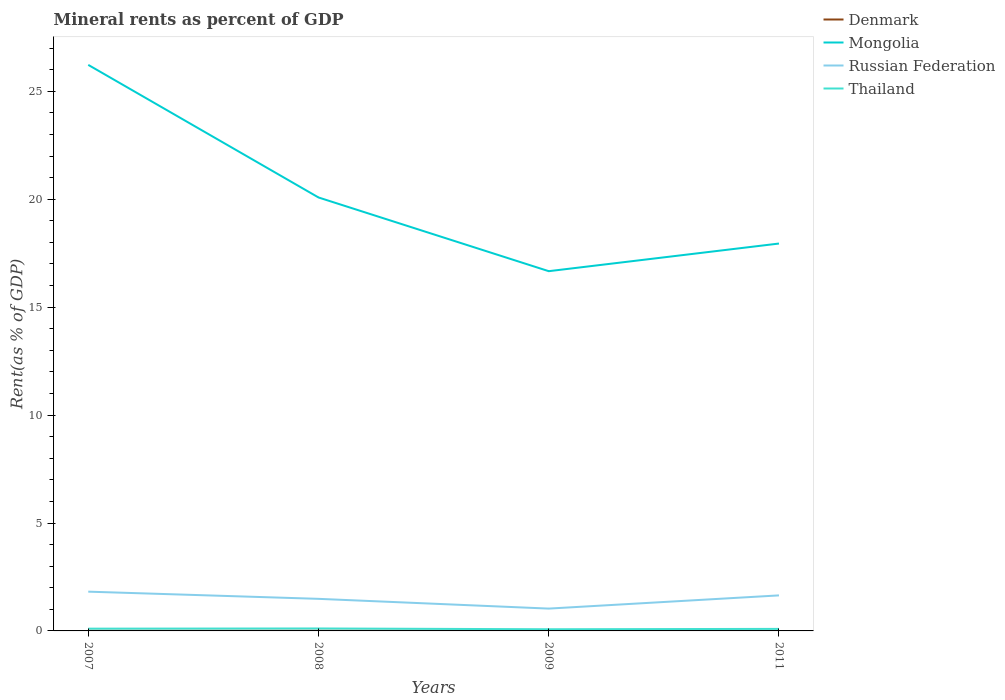Across all years, what is the maximum mineral rent in Thailand?
Your answer should be compact. 0.08. What is the total mineral rent in Russian Federation in the graph?
Provide a short and direct response. -0.16. What is the difference between the highest and the second highest mineral rent in Denmark?
Make the answer very short. 0.01. How many years are there in the graph?
Keep it short and to the point. 4. Are the values on the major ticks of Y-axis written in scientific E-notation?
Provide a succinct answer. No. Does the graph contain any zero values?
Keep it short and to the point. No. Does the graph contain grids?
Make the answer very short. No. Where does the legend appear in the graph?
Keep it short and to the point. Top right. How many legend labels are there?
Your response must be concise. 4. How are the legend labels stacked?
Provide a succinct answer. Vertical. What is the title of the graph?
Your answer should be compact. Mineral rents as percent of GDP. What is the label or title of the Y-axis?
Ensure brevity in your answer.  Rent(as % of GDP). What is the Rent(as % of GDP) in Denmark in 2007?
Your answer should be compact. 0.01. What is the Rent(as % of GDP) of Mongolia in 2007?
Your answer should be compact. 26.23. What is the Rent(as % of GDP) of Russian Federation in 2007?
Provide a succinct answer. 1.82. What is the Rent(as % of GDP) of Thailand in 2007?
Ensure brevity in your answer.  0.11. What is the Rent(as % of GDP) of Denmark in 2008?
Make the answer very short. 0.01. What is the Rent(as % of GDP) of Mongolia in 2008?
Provide a short and direct response. 20.08. What is the Rent(as % of GDP) of Russian Federation in 2008?
Provide a short and direct response. 1.49. What is the Rent(as % of GDP) in Thailand in 2008?
Make the answer very short. 0.11. What is the Rent(as % of GDP) in Denmark in 2009?
Your answer should be compact. 0.01. What is the Rent(as % of GDP) in Mongolia in 2009?
Offer a very short reply. 16.67. What is the Rent(as % of GDP) of Russian Federation in 2009?
Give a very brief answer. 1.03. What is the Rent(as % of GDP) in Thailand in 2009?
Your response must be concise. 0.08. What is the Rent(as % of GDP) in Denmark in 2011?
Give a very brief answer. 0. What is the Rent(as % of GDP) in Mongolia in 2011?
Your response must be concise. 17.95. What is the Rent(as % of GDP) of Russian Federation in 2011?
Give a very brief answer. 1.65. What is the Rent(as % of GDP) in Thailand in 2011?
Give a very brief answer. 0.09. Across all years, what is the maximum Rent(as % of GDP) of Denmark?
Provide a short and direct response. 0.01. Across all years, what is the maximum Rent(as % of GDP) of Mongolia?
Provide a short and direct response. 26.23. Across all years, what is the maximum Rent(as % of GDP) in Russian Federation?
Your response must be concise. 1.82. Across all years, what is the maximum Rent(as % of GDP) of Thailand?
Provide a short and direct response. 0.11. Across all years, what is the minimum Rent(as % of GDP) in Denmark?
Your response must be concise. 0. Across all years, what is the minimum Rent(as % of GDP) in Mongolia?
Ensure brevity in your answer.  16.67. Across all years, what is the minimum Rent(as % of GDP) in Russian Federation?
Your answer should be very brief. 1.03. Across all years, what is the minimum Rent(as % of GDP) in Thailand?
Give a very brief answer. 0.08. What is the total Rent(as % of GDP) of Denmark in the graph?
Provide a short and direct response. 0.02. What is the total Rent(as % of GDP) in Mongolia in the graph?
Give a very brief answer. 80.92. What is the total Rent(as % of GDP) of Russian Federation in the graph?
Offer a very short reply. 5.99. What is the total Rent(as % of GDP) in Thailand in the graph?
Offer a very short reply. 0.39. What is the difference between the Rent(as % of GDP) of Denmark in 2007 and that in 2008?
Your answer should be compact. -0. What is the difference between the Rent(as % of GDP) of Mongolia in 2007 and that in 2008?
Provide a succinct answer. 6.14. What is the difference between the Rent(as % of GDP) in Russian Federation in 2007 and that in 2008?
Provide a short and direct response. 0.33. What is the difference between the Rent(as % of GDP) in Thailand in 2007 and that in 2008?
Keep it short and to the point. -0.01. What is the difference between the Rent(as % of GDP) of Denmark in 2007 and that in 2009?
Ensure brevity in your answer.  -0. What is the difference between the Rent(as % of GDP) in Mongolia in 2007 and that in 2009?
Your answer should be compact. 9.56. What is the difference between the Rent(as % of GDP) in Russian Federation in 2007 and that in 2009?
Your answer should be very brief. 0.78. What is the difference between the Rent(as % of GDP) in Thailand in 2007 and that in 2009?
Keep it short and to the point. 0.03. What is the difference between the Rent(as % of GDP) of Denmark in 2007 and that in 2011?
Give a very brief answer. 0.01. What is the difference between the Rent(as % of GDP) of Mongolia in 2007 and that in 2011?
Your answer should be very brief. 8.28. What is the difference between the Rent(as % of GDP) in Russian Federation in 2007 and that in 2011?
Provide a short and direct response. 0.17. What is the difference between the Rent(as % of GDP) of Thailand in 2007 and that in 2011?
Provide a short and direct response. 0.01. What is the difference between the Rent(as % of GDP) in Denmark in 2008 and that in 2009?
Keep it short and to the point. 0. What is the difference between the Rent(as % of GDP) in Mongolia in 2008 and that in 2009?
Your response must be concise. 3.42. What is the difference between the Rent(as % of GDP) of Russian Federation in 2008 and that in 2009?
Your answer should be compact. 0.45. What is the difference between the Rent(as % of GDP) of Thailand in 2008 and that in 2009?
Keep it short and to the point. 0.04. What is the difference between the Rent(as % of GDP) in Denmark in 2008 and that in 2011?
Your response must be concise. 0.01. What is the difference between the Rent(as % of GDP) of Mongolia in 2008 and that in 2011?
Your answer should be compact. 2.13. What is the difference between the Rent(as % of GDP) in Russian Federation in 2008 and that in 2011?
Your response must be concise. -0.16. What is the difference between the Rent(as % of GDP) of Thailand in 2008 and that in 2011?
Provide a succinct answer. 0.02. What is the difference between the Rent(as % of GDP) in Denmark in 2009 and that in 2011?
Offer a terse response. 0.01. What is the difference between the Rent(as % of GDP) of Mongolia in 2009 and that in 2011?
Keep it short and to the point. -1.28. What is the difference between the Rent(as % of GDP) in Russian Federation in 2009 and that in 2011?
Provide a short and direct response. -0.61. What is the difference between the Rent(as % of GDP) of Thailand in 2009 and that in 2011?
Your answer should be compact. -0.02. What is the difference between the Rent(as % of GDP) of Denmark in 2007 and the Rent(as % of GDP) of Mongolia in 2008?
Make the answer very short. -20.08. What is the difference between the Rent(as % of GDP) of Denmark in 2007 and the Rent(as % of GDP) of Russian Federation in 2008?
Your answer should be very brief. -1.48. What is the difference between the Rent(as % of GDP) in Denmark in 2007 and the Rent(as % of GDP) in Thailand in 2008?
Ensure brevity in your answer.  -0.11. What is the difference between the Rent(as % of GDP) in Mongolia in 2007 and the Rent(as % of GDP) in Russian Federation in 2008?
Your answer should be very brief. 24.74. What is the difference between the Rent(as % of GDP) in Mongolia in 2007 and the Rent(as % of GDP) in Thailand in 2008?
Offer a terse response. 26.11. What is the difference between the Rent(as % of GDP) of Russian Federation in 2007 and the Rent(as % of GDP) of Thailand in 2008?
Your response must be concise. 1.71. What is the difference between the Rent(as % of GDP) of Denmark in 2007 and the Rent(as % of GDP) of Mongolia in 2009?
Offer a very short reply. -16.66. What is the difference between the Rent(as % of GDP) of Denmark in 2007 and the Rent(as % of GDP) of Russian Federation in 2009?
Provide a succinct answer. -1.03. What is the difference between the Rent(as % of GDP) in Denmark in 2007 and the Rent(as % of GDP) in Thailand in 2009?
Provide a succinct answer. -0.07. What is the difference between the Rent(as % of GDP) in Mongolia in 2007 and the Rent(as % of GDP) in Russian Federation in 2009?
Your answer should be compact. 25.19. What is the difference between the Rent(as % of GDP) of Mongolia in 2007 and the Rent(as % of GDP) of Thailand in 2009?
Provide a short and direct response. 26.15. What is the difference between the Rent(as % of GDP) in Russian Federation in 2007 and the Rent(as % of GDP) in Thailand in 2009?
Keep it short and to the point. 1.74. What is the difference between the Rent(as % of GDP) of Denmark in 2007 and the Rent(as % of GDP) of Mongolia in 2011?
Offer a terse response. -17.94. What is the difference between the Rent(as % of GDP) of Denmark in 2007 and the Rent(as % of GDP) of Russian Federation in 2011?
Offer a terse response. -1.64. What is the difference between the Rent(as % of GDP) of Denmark in 2007 and the Rent(as % of GDP) of Thailand in 2011?
Provide a short and direct response. -0.09. What is the difference between the Rent(as % of GDP) in Mongolia in 2007 and the Rent(as % of GDP) in Russian Federation in 2011?
Keep it short and to the point. 24.58. What is the difference between the Rent(as % of GDP) in Mongolia in 2007 and the Rent(as % of GDP) in Thailand in 2011?
Ensure brevity in your answer.  26.13. What is the difference between the Rent(as % of GDP) in Russian Federation in 2007 and the Rent(as % of GDP) in Thailand in 2011?
Make the answer very short. 1.73. What is the difference between the Rent(as % of GDP) in Denmark in 2008 and the Rent(as % of GDP) in Mongolia in 2009?
Offer a very short reply. -16.66. What is the difference between the Rent(as % of GDP) of Denmark in 2008 and the Rent(as % of GDP) of Russian Federation in 2009?
Your answer should be very brief. -1.03. What is the difference between the Rent(as % of GDP) in Denmark in 2008 and the Rent(as % of GDP) in Thailand in 2009?
Give a very brief answer. -0.07. What is the difference between the Rent(as % of GDP) of Mongolia in 2008 and the Rent(as % of GDP) of Russian Federation in 2009?
Provide a short and direct response. 19.05. What is the difference between the Rent(as % of GDP) in Mongolia in 2008 and the Rent(as % of GDP) in Thailand in 2009?
Your response must be concise. 20. What is the difference between the Rent(as % of GDP) of Russian Federation in 2008 and the Rent(as % of GDP) of Thailand in 2009?
Your answer should be very brief. 1.41. What is the difference between the Rent(as % of GDP) in Denmark in 2008 and the Rent(as % of GDP) in Mongolia in 2011?
Offer a very short reply. -17.94. What is the difference between the Rent(as % of GDP) in Denmark in 2008 and the Rent(as % of GDP) in Russian Federation in 2011?
Provide a short and direct response. -1.64. What is the difference between the Rent(as % of GDP) of Denmark in 2008 and the Rent(as % of GDP) of Thailand in 2011?
Provide a succinct answer. -0.09. What is the difference between the Rent(as % of GDP) in Mongolia in 2008 and the Rent(as % of GDP) in Russian Federation in 2011?
Provide a succinct answer. 18.44. What is the difference between the Rent(as % of GDP) in Mongolia in 2008 and the Rent(as % of GDP) in Thailand in 2011?
Give a very brief answer. 19.99. What is the difference between the Rent(as % of GDP) in Russian Federation in 2008 and the Rent(as % of GDP) in Thailand in 2011?
Ensure brevity in your answer.  1.39. What is the difference between the Rent(as % of GDP) in Denmark in 2009 and the Rent(as % of GDP) in Mongolia in 2011?
Offer a terse response. -17.94. What is the difference between the Rent(as % of GDP) in Denmark in 2009 and the Rent(as % of GDP) in Russian Federation in 2011?
Your response must be concise. -1.64. What is the difference between the Rent(as % of GDP) in Denmark in 2009 and the Rent(as % of GDP) in Thailand in 2011?
Provide a short and direct response. -0.09. What is the difference between the Rent(as % of GDP) in Mongolia in 2009 and the Rent(as % of GDP) in Russian Federation in 2011?
Keep it short and to the point. 15.02. What is the difference between the Rent(as % of GDP) in Mongolia in 2009 and the Rent(as % of GDP) in Thailand in 2011?
Give a very brief answer. 16.57. What is the difference between the Rent(as % of GDP) of Russian Federation in 2009 and the Rent(as % of GDP) of Thailand in 2011?
Give a very brief answer. 0.94. What is the average Rent(as % of GDP) of Denmark per year?
Provide a succinct answer. 0.01. What is the average Rent(as % of GDP) of Mongolia per year?
Make the answer very short. 20.23. What is the average Rent(as % of GDP) in Russian Federation per year?
Provide a succinct answer. 1.5. What is the average Rent(as % of GDP) in Thailand per year?
Your response must be concise. 0.1. In the year 2007, what is the difference between the Rent(as % of GDP) of Denmark and Rent(as % of GDP) of Mongolia?
Your response must be concise. -26.22. In the year 2007, what is the difference between the Rent(as % of GDP) of Denmark and Rent(as % of GDP) of Russian Federation?
Offer a terse response. -1.81. In the year 2007, what is the difference between the Rent(as % of GDP) in Denmark and Rent(as % of GDP) in Thailand?
Offer a very short reply. -0.1. In the year 2007, what is the difference between the Rent(as % of GDP) in Mongolia and Rent(as % of GDP) in Russian Federation?
Provide a succinct answer. 24.41. In the year 2007, what is the difference between the Rent(as % of GDP) of Mongolia and Rent(as % of GDP) of Thailand?
Offer a terse response. 26.12. In the year 2007, what is the difference between the Rent(as % of GDP) in Russian Federation and Rent(as % of GDP) in Thailand?
Provide a succinct answer. 1.71. In the year 2008, what is the difference between the Rent(as % of GDP) in Denmark and Rent(as % of GDP) in Mongolia?
Your answer should be very brief. -20.07. In the year 2008, what is the difference between the Rent(as % of GDP) of Denmark and Rent(as % of GDP) of Russian Federation?
Provide a short and direct response. -1.48. In the year 2008, what is the difference between the Rent(as % of GDP) in Denmark and Rent(as % of GDP) in Thailand?
Your answer should be compact. -0.11. In the year 2008, what is the difference between the Rent(as % of GDP) in Mongolia and Rent(as % of GDP) in Russian Federation?
Make the answer very short. 18.6. In the year 2008, what is the difference between the Rent(as % of GDP) of Mongolia and Rent(as % of GDP) of Thailand?
Offer a terse response. 19.97. In the year 2008, what is the difference between the Rent(as % of GDP) in Russian Federation and Rent(as % of GDP) in Thailand?
Your response must be concise. 1.37. In the year 2009, what is the difference between the Rent(as % of GDP) of Denmark and Rent(as % of GDP) of Mongolia?
Your answer should be compact. -16.66. In the year 2009, what is the difference between the Rent(as % of GDP) of Denmark and Rent(as % of GDP) of Russian Federation?
Give a very brief answer. -1.03. In the year 2009, what is the difference between the Rent(as % of GDP) in Denmark and Rent(as % of GDP) in Thailand?
Your answer should be very brief. -0.07. In the year 2009, what is the difference between the Rent(as % of GDP) in Mongolia and Rent(as % of GDP) in Russian Federation?
Your answer should be compact. 15.63. In the year 2009, what is the difference between the Rent(as % of GDP) of Mongolia and Rent(as % of GDP) of Thailand?
Keep it short and to the point. 16.59. In the year 2009, what is the difference between the Rent(as % of GDP) of Russian Federation and Rent(as % of GDP) of Thailand?
Your response must be concise. 0.96. In the year 2011, what is the difference between the Rent(as % of GDP) in Denmark and Rent(as % of GDP) in Mongolia?
Offer a very short reply. -17.95. In the year 2011, what is the difference between the Rent(as % of GDP) in Denmark and Rent(as % of GDP) in Russian Federation?
Keep it short and to the point. -1.64. In the year 2011, what is the difference between the Rent(as % of GDP) of Denmark and Rent(as % of GDP) of Thailand?
Make the answer very short. -0.09. In the year 2011, what is the difference between the Rent(as % of GDP) of Mongolia and Rent(as % of GDP) of Russian Federation?
Keep it short and to the point. 16.3. In the year 2011, what is the difference between the Rent(as % of GDP) of Mongolia and Rent(as % of GDP) of Thailand?
Provide a short and direct response. 17.85. In the year 2011, what is the difference between the Rent(as % of GDP) in Russian Federation and Rent(as % of GDP) in Thailand?
Offer a very short reply. 1.55. What is the ratio of the Rent(as % of GDP) in Denmark in 2007 to that in 2008?
Give a very brief answer. 0.88. What is the ratio of the Rent(as % of GDP) of Mongolia in 2007 to that in 2008?
Your answer should be very brief. 1.31. What is the ratio of the Rent(as % of GDP) of Russian Federation in 2007 to that in 2008?
Provide a short and direct response. 1.22. What is the ratio of the Rent(as % of GDP) of Thailand in 2007 to that in 2008?
Provide a succinct answer. 0.93. What is the ratio of the Rent(as % of GDP) in Denmark in 2007 to that in 2009?
Ensure brevity in your answer.  0.96. What is the ratio of the Rent(as % of GDP) of Mongolia in 2007 to that in 2009?
Your response must be concise. 1.57. What is the ratio of the Rent(as % of GDP) in Russian Federation in 2007 to that in 2009?
Offer a terse response. 1.76. What is the ratio of the Rent(as % of GDP) of Thailand in 2007 to that in 2009?
Ensure brevity in your answer.  1.36. What is the ratio of the Rent(as % of GDP) in Denmark in 2007 to that in 2011?
Give a very brief answer. 3.99. What is the ratio of the Rent(as % of GDP) of Mongolia in 2007 to that in 2011?
Provide a short and direct response. 1.46. What is the ratio of the Rent(as % of GDP) of Russian Federation in 2007 to that in 2011?
Your answer should be compact. 1.1. What is the ratio of the Rent(as % of GDP) in Thailand in 2007 to that in 2011?
Provide a succinct answer. 1.12. What is the ratio of the Rent(as % of GDP) of Denmark in 2008 to that in 2009?
Give a very brief answer. 1.09. What is the ratio of the Rent(as % of GDP) in Mongolia in 2008 to that in 2009?
Ensure brevity in your answer.  1.2. What is the ratio of the Rent(as % of GDP) of Russian Federation in 2008 to that in 2009?
Your response must be concise. 1.44. What is the ratio of the Rent(as % of GDP) in Thailand in 2008 to that in 2009?
Keep it short and to the point. 1.46. What is the ratio of the Rent(as % of GDP) in Denmark in 2008 to that in 2011?
Provide a short and direct response. 4.56. What is the ratio of the Rent(as % of GDP) in Mongolia in 2008 to that in 2011?
Provide a succinct answer. 1.12. What is the ratio of the Rent(as % of GDP) of Russian Federation in 2008 to that in 2011?
Your answer should be very brief. 0.9. What is the ratio of the Rent(as % of GDP) in Thailand in 2008 to that in 2011?
Your answer should be very brief. 1.21. What is the ratio of the Rent(as % of GDP) in Denmark in 2009 to that in 2011?
Offer a terse response. 4.18. What is the ratio of the Rent(as % of GDP) of Mongolia in 2009 to that in 2011?
Provide a short and direct response. 0.93. What is the ratio of the Rent(as % of GDP) of Russian Federation in 2009 to that in 2011?
Give a very brief answer. 0.63. What is the ratio of the Rent(as % of GDP) in Thailand in 2009 to that in 2011?
Offer a terse response. 0.83. What is the difference between the highest and the second highest Rent(as % of GDP) of Denmark?
Make the answer very short. 0. What is the difference between the highest and the second highest Rent(as % of GDP) in Mongolia?
Your answer should be very brief. 6.14. What is the difference between the highest and the second highest Rent(as % of GDP) of Russian Federation?
Make the answer very short. 0.17. What is the difference between the highest and the second highest Rent(as % of GDP) in Thailand?
Your answer should be compact. 0.01. What is the difference between the highest and the lowest Rent(as % of GDP) of Denmark?
Offer a very short reply. 0.01. What is the difference between the highest and the lowest Rent(as % of GDP) of Mongolia?
Offer a very short reply. 9.56. What is the difference between the highest and the lowest Rent(as % of GDP) of Russian Federation?
Give a very brief answer. 0.78. What is the difference between the highest and the lowest Rent(as % of GDP) of Thailand?
Ensure brevity in your answer.  0.04. 